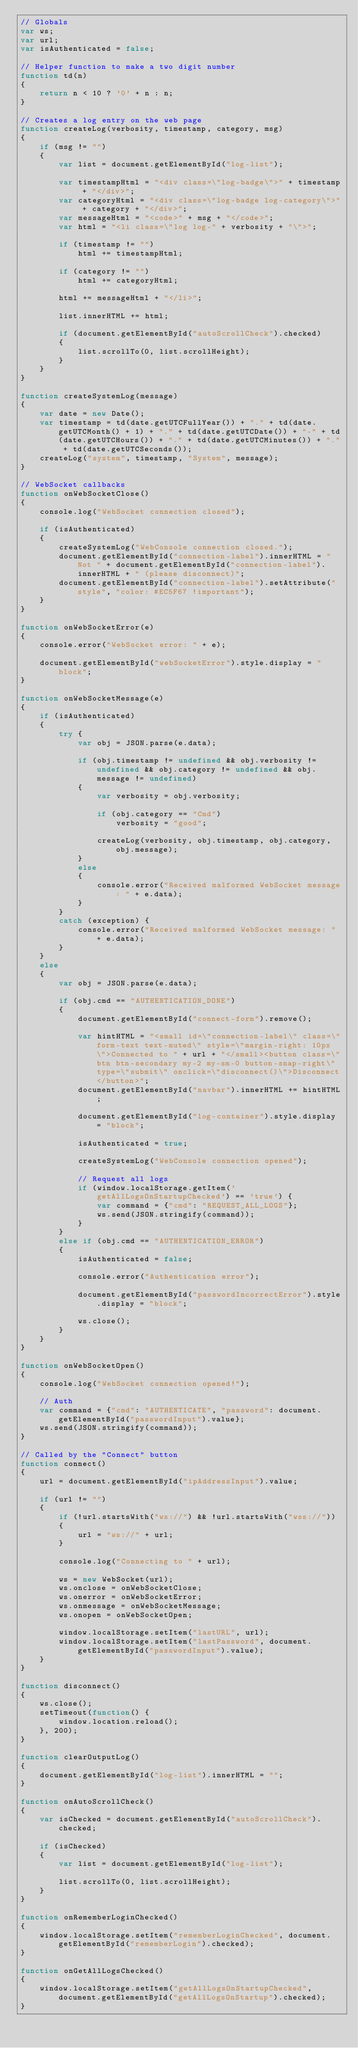Convert code to text. <code><loc_0><loc_0><loc_500><loc_500><_JavaScript_>// Globals
var ws;
var url;
var isAuthenticated = false;

// Helper function to make a two digit number
function td(n)
{
    return n < 10 ? '0' + n : n;
}

// Creates a log entry on the web page
function createLog(verbosity, timestamp, category, msg)
{
    if (msg != "")
    {
        var list = document.getElementById("log-list");

        var timestampHtml = "<div class=\"log-badge\">" + timestamp + "</div>";
        var categoryHtml = "<div class=\"log-badge log-category\">" + category + "</div>";
        var messageHtml = "<code>" + msg + "</code>";
        var html = "<li class=\"log log-" + verbosity + "\">";
        
        if (timestamp != "")
            html += timestampHtml;

        if (category != "")
            html += categoryHtml;

        html += messageHtml + "</li>";

        list.innerHTML += html;

        if (document.getElementById("autoScrollCheck").checked)
        {
            list.scrollTo(0, list.scrollHeight);
        }
    }  
}

function createSystemLog(message)
{
    var date = new Date();
    var timestamp = td(date.getUTCFullYear()) + "." + td(date.getUTCMonth() + 1) + "." + td(date.getUTCDate()) + "-" + td(date.getUTCHours()) + "." + td(date.getUTCMinutes()) + "." + td(date.getUTCSeconds());
    createLog("system", timestamp, "System", message);
}

// WebSocket callbacks
function onWebSocketClose()
{
    console.log("WebSocket connection closed");

    if (isAuthenticated)
    {
        createSystemLog("WebConsole connection closed.");
        document.getElementById("connection-label").innerHTML = "Not " + document.getElementById("connection-label").innerHTML + " (please disconnect)";
        document.getElementById("connection-label").setAttribute("style", "color: #EC5F67 !important");
    }
}

function onWebSocketError(e)
{
    console.error("WebSocket error: " + e);

    document.getElementById("webSocketError").style.display = "block";
}

function onWebSocketMessage(e)
{
    if (isAuthenticated)
    {
        try {
            var obj = JSON.parse(e.data);

            if (obj.timestamp != undefined && obj.verbosity != undefined && obj.category != undefined && obj.message != undefined)
            {
                var verbosity = obj.verbosity;

                if (obj.category == "Cmd")
                    verbosity = "good";

                createLog(verbosity, obj.timestamp, obj.category, obj.message);
            }
            else
            {
                console.error("Received malformed WebSocket message: " + e.data);
            }
        }
        catch (exception) {
            console.error("Received malformed WebSocket message: " + e.data);
        }
    }
    else
    {
        var obj = JSON.parse(e.data);

        if (obj.cmd == "AUTHENTICATION_DONE")
        {
            document.getElementById("connect-form").remove();

            var hintHTML = "<small id=\"connection-label\" class=\"form-text text-muted\" style=\"margin-right: 10px\">Connected to " + url + "</small><button class=\"btn btn-secondary my-2 my-sm-0 button-snap-right\" type=\"submit\" onclick=\"disconnect()\">Disconnect</button>";
            document.getElementById("navbar").innerHTML += hintHTML;
        
            document.getElementById("log-container").style.display = "block";

            isAuthenticated = true;

            createSystemLog("WebConsole connection opened");

            // Request all logs
			if (window.localStorage.getItem('getAllLogsOnStartupChecked') == 'true') {
				var command = {"cmd": "REQUEST_ALL_LOGS"};
				ws.send(JSON.stringify(command));
			}
        }
        else if (obj.cmd == "AUTHENTICATION_ERROR")
        {
            isAuthenticated = false;

            console.error("Authentication error");

            document.getElementById("passwordIncorrectError").style.display = "block";

            ws.close();
        }
    }
}

function onWebSocketOpen()
{
    console.log("WebSocket connection opened!");

    // Auth
    var command = {"cmd": "AUTHENTICATE", "password": document.getElementById("passwordInput").value};
    ws.send(JSON.stringify(command));
}

// Called by the "Connect" button
function connect()
{
    url = document.getElementById("ipAddressInput").value;

    if (url != "")
    {
        if (!url.startsWith("ws://") && !url.startsWith("wss://"))
        {
            url = "ws://" + url;
        }

        console.log("Connecting to " + url);

        ws = new WebSocket(url);
        ws.onclose = onWebSocketClose;
        ws.onerror = onWebSocketError;
        ws.onmessage = onWebSocketMessage;
        ws.onopen = onWebSocketOpen;
		
		window.localStorage.setItem("lastURL", url);
		window.localStorage.setItem("lastPassword", document.getElementById("passwordInput").value);
    }
}

function disconnect()
{
    ws.close();
    setTimeout(function() {
        window.location.reload();
    }, 200);
}

function clearOutputLog()
{
    document.getElementById("log-list").innerHTML = "";
}

function onAutoScrollCheck()
{
    var isChecked = document.getElementById("autoScrollCheck").checked;

    if (isChecked)
    {
        var list = document.getElementById("log-list");

        list.scrollTo(0, list.scrollHeight);
    }
}

function onRememberLoginChecked()
{
	window.localStorage.setItem("rememberLoginChecked", document.getElementById("rememberLogin").checked);
}

function onGetAllLogsChecked()
{
	window.localStorage.setItem("getAllLogsOnStartupChecked", document.getElementById("getAllLogsOnStartup").checked);
}
</code> 